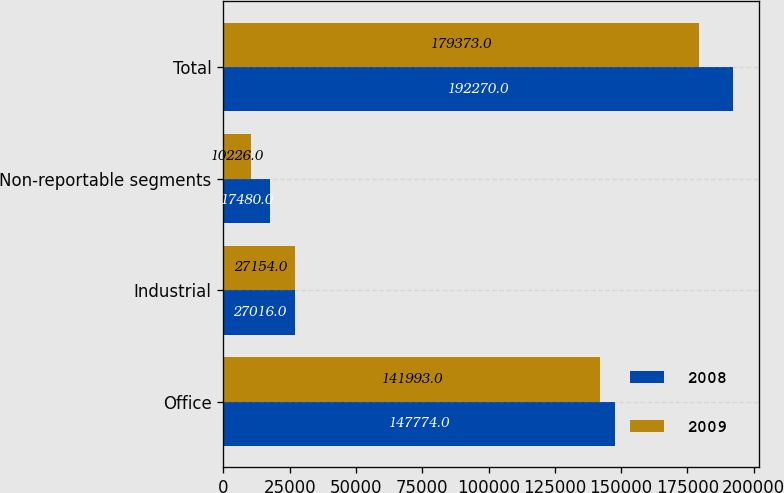Convert chart to OTSL. <chart><loc_0><loc_0><loc_500><loc_500><stacked_bar_chart><ecel><fcel>Office<fcel>Industrial<fcel>Non-reportable segments<fcel>Total<nl><fcel>2008<fcel>147774<fcel>27016<fcel>17480<fcel>192270<nl><fcel>2009<fcel>141993<fcel>27154<fcel>10226<fcel>179373<nl></chart> 